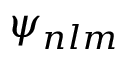<formula> <loc_0><loc_0><loc_500><loc_500>\psi _ { n l m }</formula> 